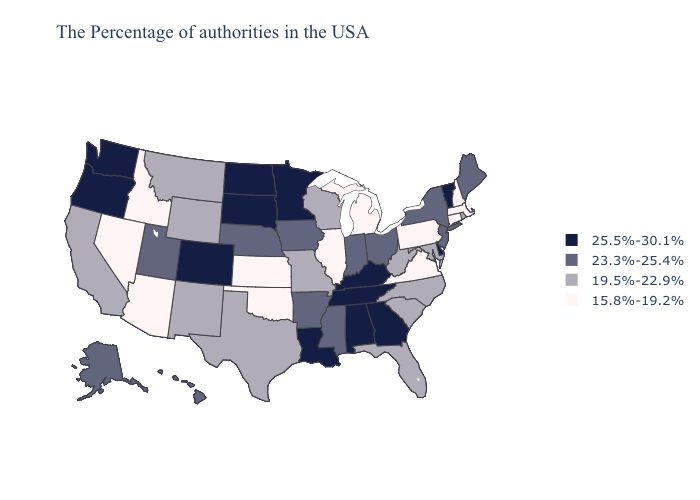Name the states that have a value in the range 25.5%-30.1%?
Write a very short answer. Vermont, Delaware, Georgia, Kentucky, Alabama, Tennessee, Louisiana, Minnesota, South Dakota, North Dakota, Colorado, Washington, Oregon. What is the value of Arkansas?
Concise answer only. 23.3%-25.4%. Does Colorado have the same value as Alaska?
Write a very short answer. No. What is the highest value in states that border Louisiana?
Short answer required. 23.3%-25.4%. What is the value of Mississippi?
Answer briefly. 23.3%-25.4%. Name the states that have a value in the range 23.3%-25.4%?
Answer briefly. Maine, New York, New Jersey, Ohio, Indiana, Mississippi, Arkansas, Iowa, Nebraska, Utah, Alaska, Hawaii. Which states have the lowest value in the USA?
Quick response, please. Massachusetts, New Hampshire, Connecticut, Pennsylvania, Virginia, Michigan, Illinois, Kansas, Oklahoma, Arizona, Idaho, Nevada. Name the states that have a value in the range 19.5%-22.9%?
Keep it brief. Rhode Island, Maryland, North Carolina, South Carolina, West Virginia, Florida, Wisconsin, Missouri, Texas, Wyoming, New Mexico, Montana, California. What is the highest value in the MidWest ?
Give a very brief answer. 25.5%-30.1%. Which states have the lowest value in the MidWest?
Be succinct. Michigan, Illinois, Kansas. Name the states that have a value in the range 15.8%-19.2%?
Give a very brief answer. Massachusetts, New Hampshire, Connecticut, Pennsylvania, Virginia, Michigan, Illinois, Kansas, Oklahoma, Arizona, Idaho, Nevada. Name the states that have a value in the range 23.3%-25.4%?
Write a very short answer. Maine, New York, New Jersey, Ohio, Indiana, Mississippi, Arkansas, Iowa, Nebraska, Utah, Alaska, Hawaii. Which states have the highest value in the USA?
Write a very short answer. Vermont, Delaware, Georgia, Kentucky, Alabama, Tennessee, Louisiana, Minnesota, South Dakota, North Dakota, Colorado, Washington, Oregon. Does Rhode Island have the highest value in the USA?
Quick response, please. No. What is the value of Florida?
Concise answer only. 19.5%-22.9%. 